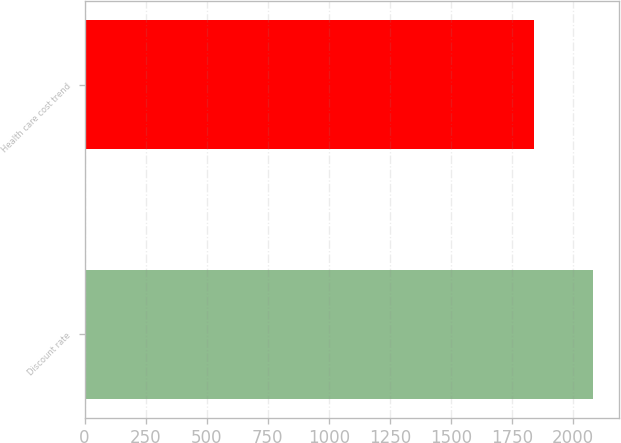<chart> <loc_0><loc_0><loc_500><loc_500><bar_chart><fcel>Discount rate<fcel>Health care cost trend<nl><fcel>2082<fcel>1841<nl></chart> 